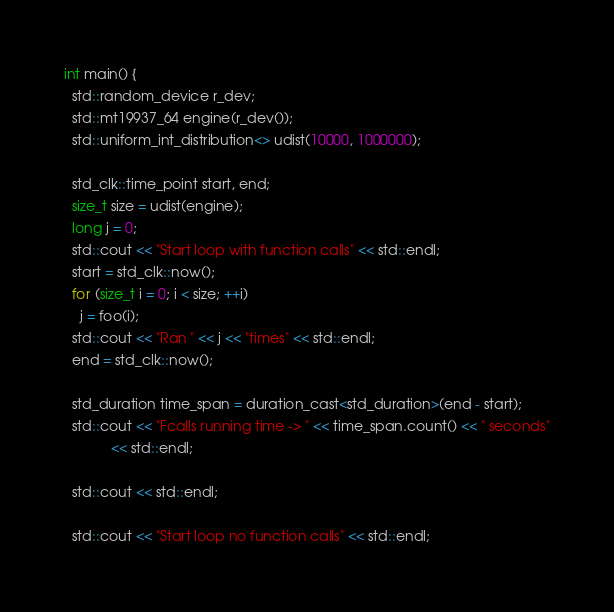Convert code to text. <code><loc_0><loc_0><loc_500><loc_500><_C++_>int main() {
  std::random_device r_dev;
  std::mt19937_64 engine(r_dev());
  std::uniform_int_distribution<> udist(10000, 1000000);

  std_clk::time_point start, end;
  size_t size = udist(engine);
  long j = 0;
  std::cout << "Start loop with function calls" << std::endl;
  start = std_clk::now();
  for (size_t i = 0; i < size; ++i)
    j = foo(i);
  std::cout << "Ran " << j << "times" << std::endl;
  end = std_clk::now();

  std_duration time_span = duration_cast<std_duration>(end - start);
  std::cout << "Fcalls running time -> " << time_span.count() << " seconds"
            << std::endl;

  std::cout << std::endl;

  std::cout << "Start loop no function calls" << std::endl;
</code> 